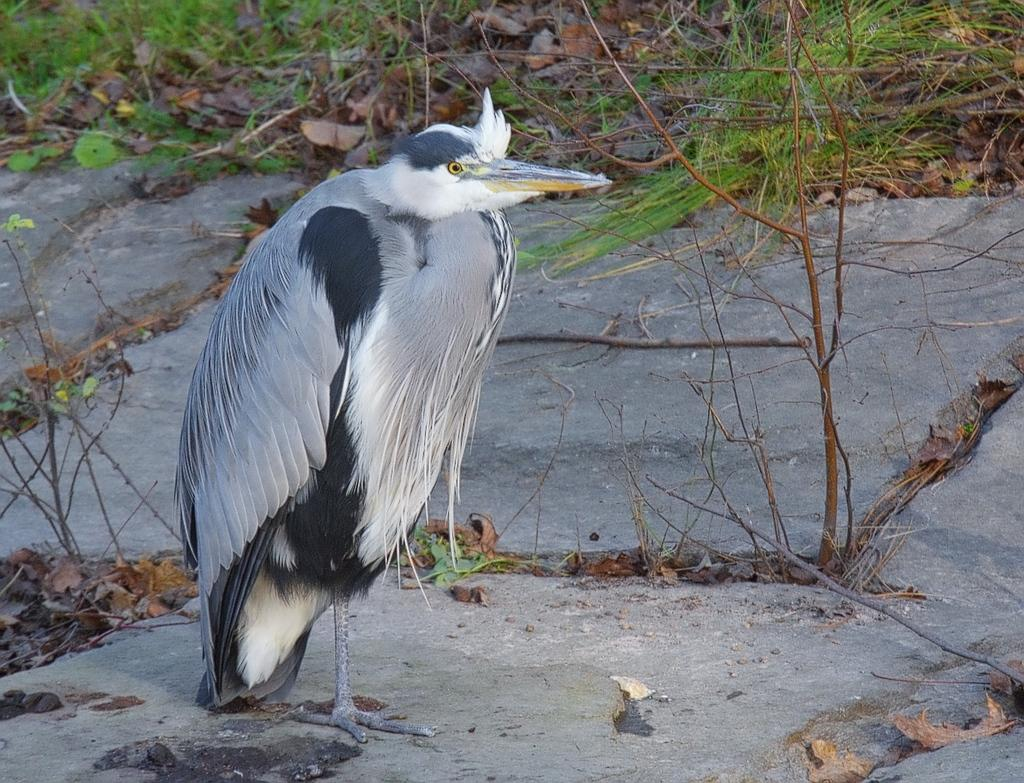What type of bird is in the image? There is a Black-crowned night heron bird in the image. Where is the bird standing? The bird is standing on a rock. What type of vegetation is present in the image? There is grass in the image. What other natural elements can be seen in the image? There are dry leaves and dry sticks in the image. What type of ear is visible on the bird in the image? Birds do not have ears like humans, so there is no ear visible on the bird in the image. 